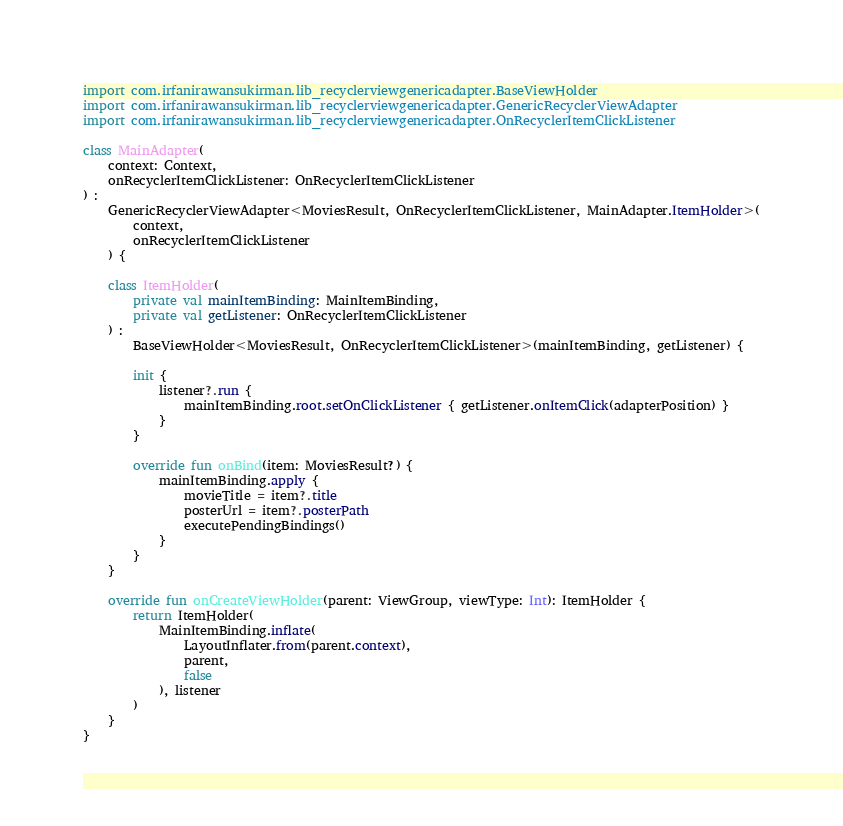<code> <loc_0><loc_0><loc_500><loc_500><_Kotlin_>import com.irfanirawansukirman.lib_recyclerviewgenericadapter.BaseViewHolder
import com.irfanirawansukirman.lib_recyclerviewgenericadapter.GenericRecyclerViewAdapter
import com.irfanirawansukirman.lib_recyclerviewgenericadapter.OnRecyclerItemClickListener

class MainAdapter(
    context: Context,
    onRecyclerItemClickListener: OnRecyclerItemClickListener
) :
    GenericRecyclerViewAdapter<MoviesResult, OnRecyclerItemClickListener, MainAdapter.ItemHolder>(
        context,
        onRecyclerItemClickListener
    ) {

    class ItemHolder(
        private val mainItemBinding: MainItemBinding,
        private val getListener: OnRecyclerItemClickListener
    ) :
        BaseViewHolder<MoviesResult, OnRecyclerItemClickListener>(mainItemBinding, getListener) {

        init {
            listener?.run {
                mainItemBinding.root.setOnClickListener { getListener.onItemClick(adapterPosition) }
            }
        }

        override fun onBind(item: MoviesResult?) {
            mainItemBinding.apply {
                movieTitle = item?.title
                posterUrl = item?.posterPath
                executePendingBindings()
            }
        }
    }

    override fun onCreateViewHolder(parent: ViewGroup, viewType: Int): ItemHolder {
        return ItemHolder(
            MainItemBinding.inflate(
                LayoutInflater.from(parent.context),
                parent,
                false
            ), listener
        )
    }
}</code> 